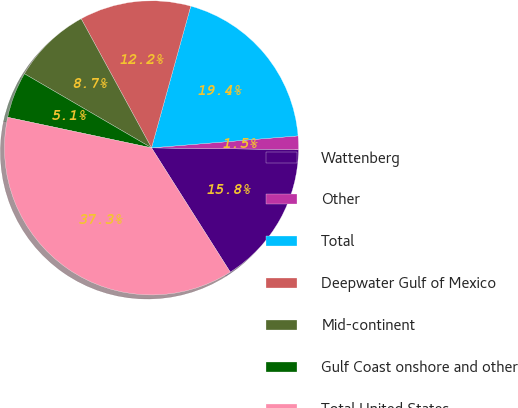Convert chart. <chart><loc_0><loc_0><loc_500><loc_500><pie_chart><fcel>Wattenberg<fcel>Other<fcel>Total<fcel>Deepwater Gulf of Mexico<fcel>Mid-continent<fcel>Gulf Coast onshore and other<fcel>Total United States<nl><fcel>15.82%<fcel>1.49%<fcel>19.4%<fcel>12.24%<fcel>8.66%<fcel>5.07%<fcel>37.32%<nl></chart> 